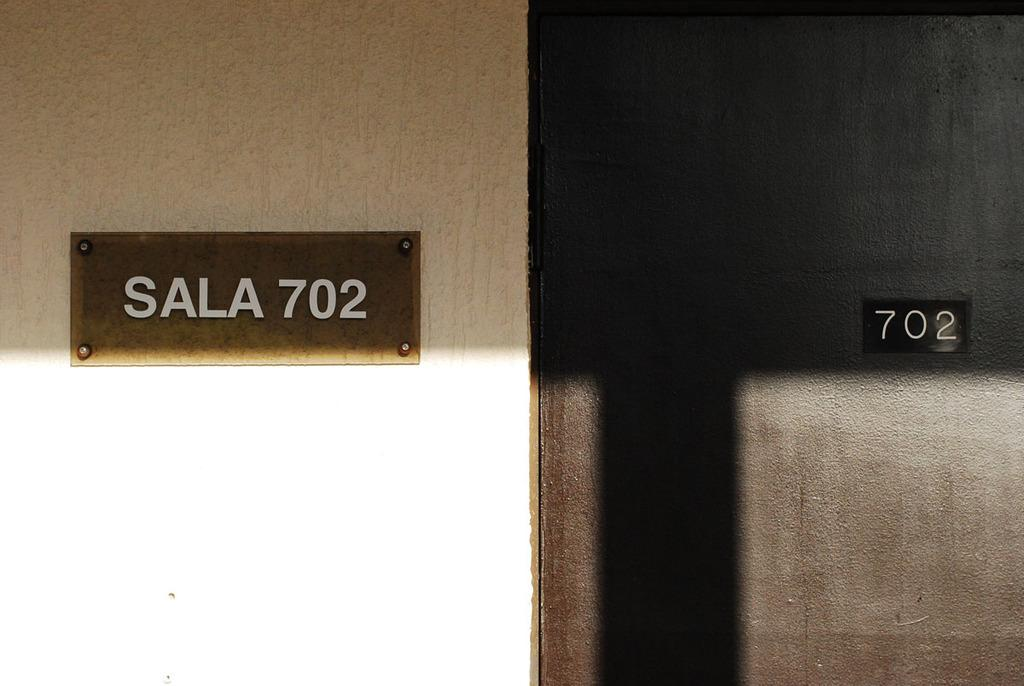What color is the door in the image? The door in the image is brown. Where is the door located in the image? The door is at the right side of the image. What number is written on the door? The number "702" is written on the door. What other object can be seen in the image related to the door? There is a name board in the image. Where is the name board located in the image? The name board is on a white wall. What type of bears are depicted on the name board in the image? There are no bears depicted on the name board in the image; it is on a white wall with a name written on it. 